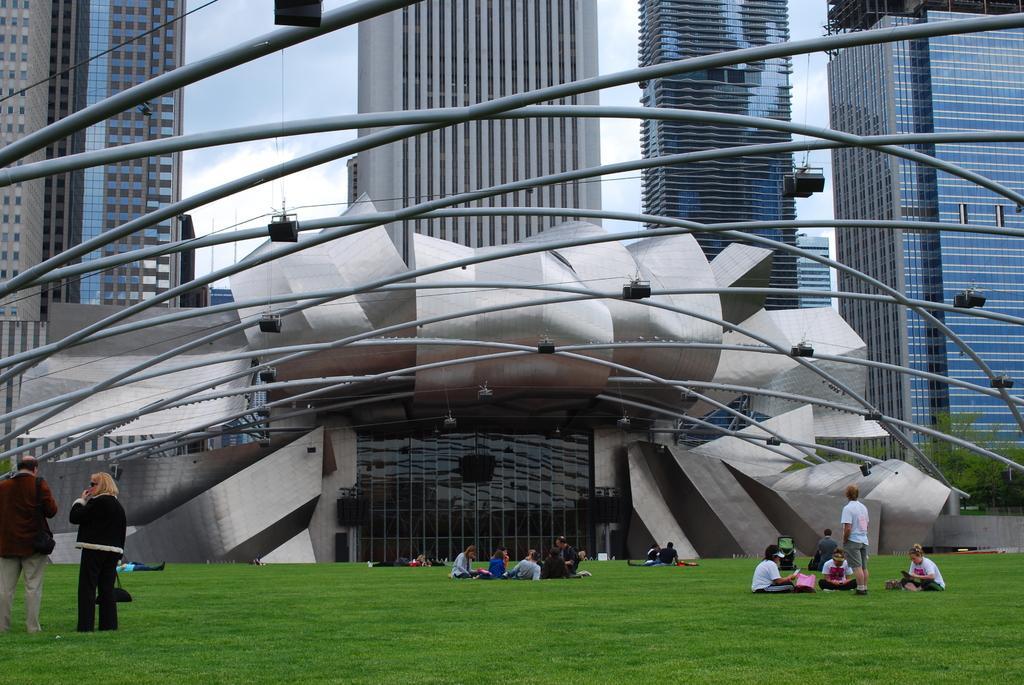How would you summarize this image in a sentence or two? In this image we can see the people sitting. We can also see three persons standing. In the background we can see the buildings and also house and rods with some focus lights. We can also see the sky with some clouds and at the bottom we can see the grass. On the right we can see the trees. 